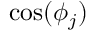<formula> <loc_0><loc_0><loc_500><loc_500>\cos ( \phi _ { j } )</formula> 